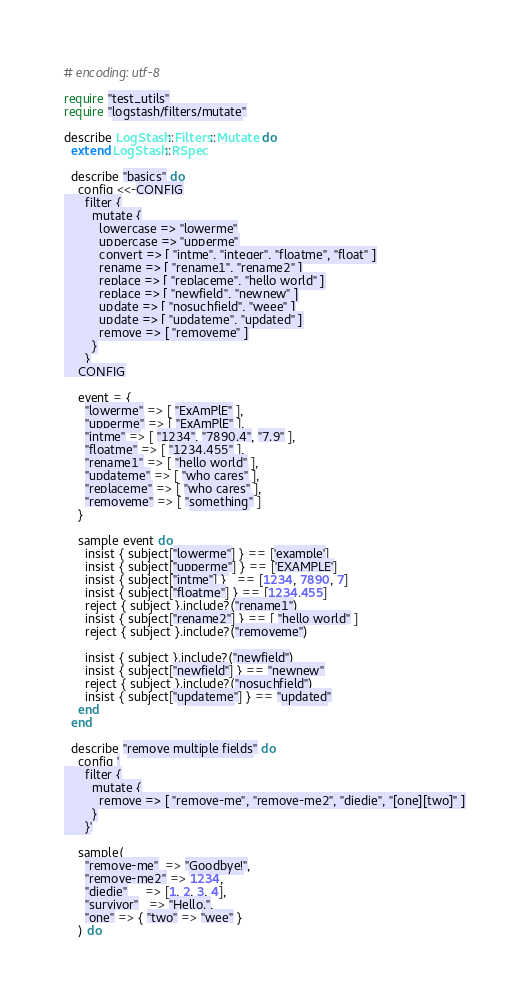<code> <loc_0><loc_0><loc_500><loc_500><_Ruby_># encoding: utf-8

require "test_utils"
require "logstash/filters/mutate"

describe LogStash::Filters::Mutate do
  extend LogStash::RSpec

  describe "basics" do
    config <<-CONFIG
      filter {
        mutate {
          lowercase => "lowerme"
          uppercase => "upperme"
          convert => [ "intme", "integer", "floatme", "float" ]
          rename => [ "rename1", "rename2" ]
          replace => [ "replaceme", "hello world" ]
          replace => [ "newfield", "newnew" ]
          update => [ "nosuchfield", "weee" ]
          update => [ "updateme", "updated" ]
          remove => [ "removeme" ]
        }
      }
    CONFIG

    event = {
      "lowerme" => [ "ExAmPlE" ],
      "upperme" => [ "ExAmPlE" ],
      "intme" => [ "1234", "7890.4", "7.9" ],
      "floatme" => [ "1234.455" ],
      "rename1" => [ "hello world" ],
      "updateme" => [ "who cares" ],
      "replaceme" => [ "who cares" ],
      "removeme" => [ "something" ]
    }

    sample event do
      insist { subject["lowerme"] } == ['example']
      insist { subject["upperme"] } == ['EXAMPLE']
      insist { subject["intme"] }   == [1234, 7890, 7]
      insist { subject["floatme"] } == [1234.455]
      reject { subject }.include?("rename1")
      insist { subject["rename2"] } == [ "hello world" ]
      reject { subject }.include?("removeme")

      insist { subject }.include?("newfield")
      insist { subject["newfield"] } == "newnew"
      reject { subject }.include?("nosuchfield")
      insist { subject["updateme"] } == "updated"
    end
  end

  describe "remove multiple fields" do
    config '
      filter {
        mutate {
          remove => [ "remove-me", "remove-me2", "diedie", "[one][two]" ]
        }
      }'

    sample(
      "remove-me"  => "Goodbye!",
      "remove-me2" => 1234,
      "diedie"     => [1, 2, 3, 4],
      "survivor"   => "Hello.",
      "one" => { "two" => "wee" }
    ) do</code> 